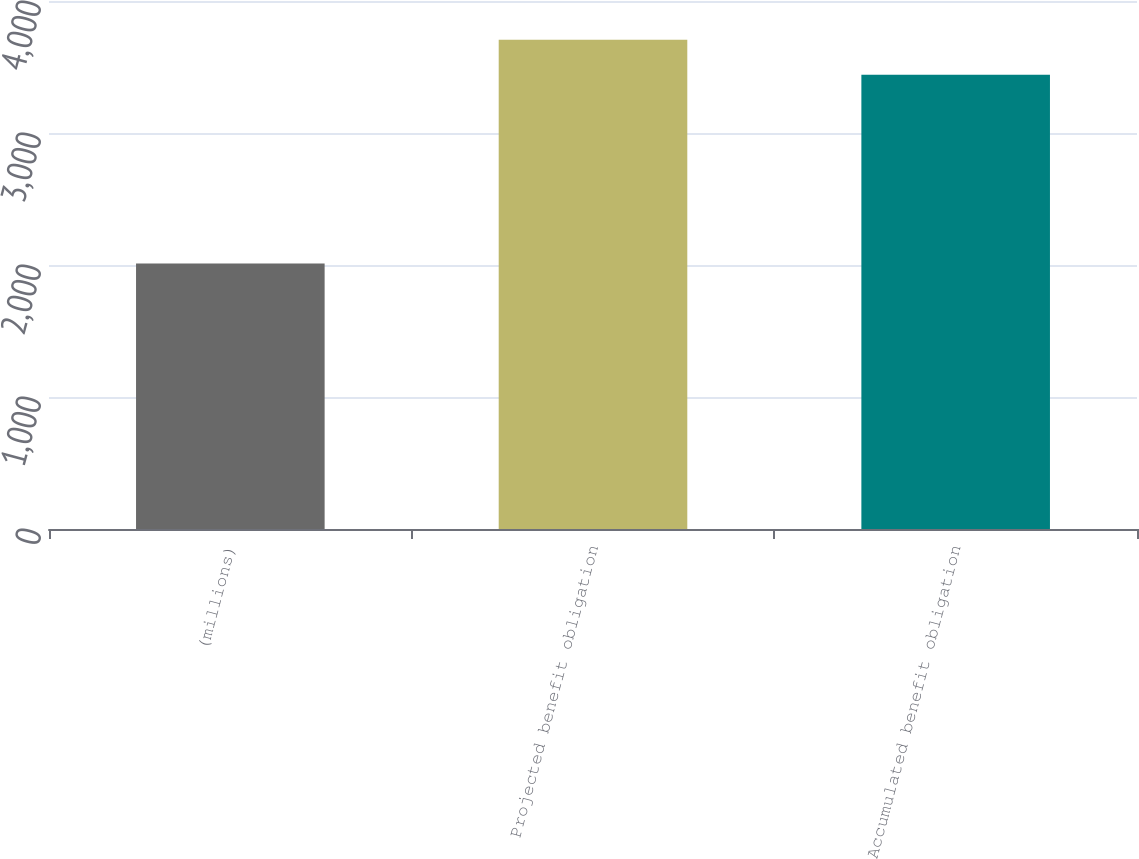Convert chart. <chart><loc_0><loc_0><loc_500><loc_500><bar_chart><fcel>(millions)<fcel>Projected benefit obligation<fcel>Accumulated benefit obligation<nl><fcel>2012<fcel>3707<fcel>3442<nl></chart> 